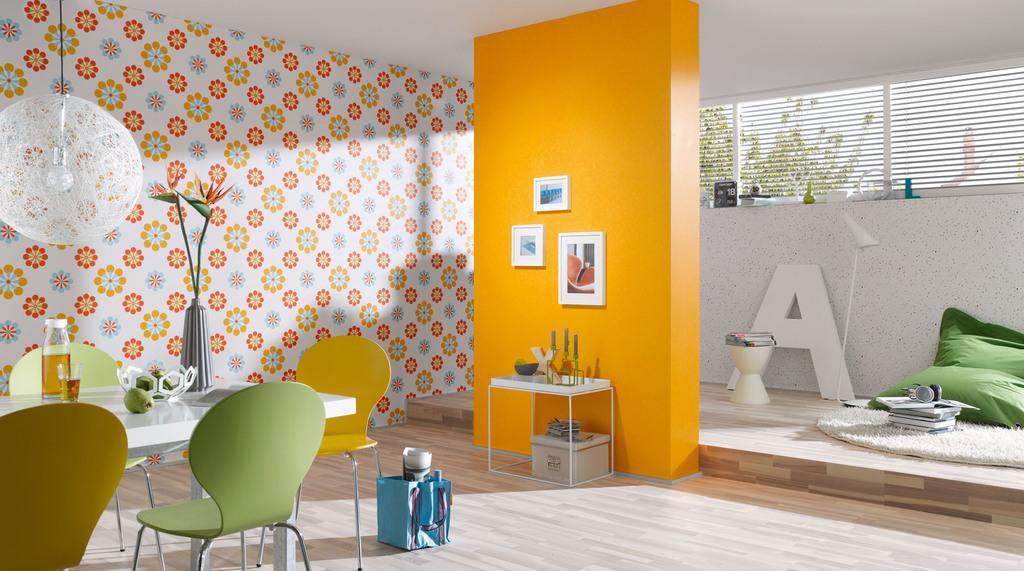In one or two sentences, can you explain what this image depicts? This is the picture of a room in which there are some chairs around the table, desk on which there are some things, frames, stool and a lamb to the roof. 